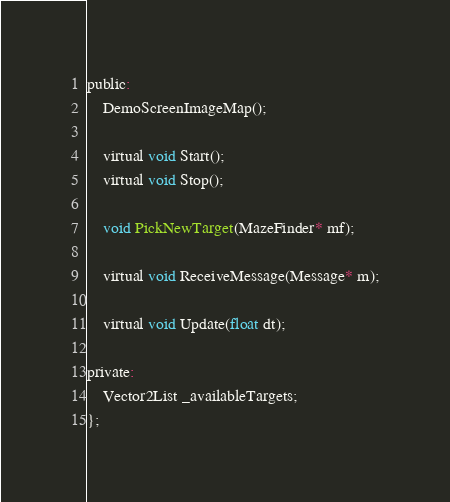<code> <loc_0><loc_0><loc_500><loc_500><_C_>public:
	DemoScreenImageMap();
	
	virtual void Start();
    virtual void Stop();

	void PickNewTarget(MazeFinder* mf);
	
	virtual void ReceiveMessage(Message* m);
	
	virtual void Update(float dt);

private:
	Vector2List _availableTargets;
};
</code> 